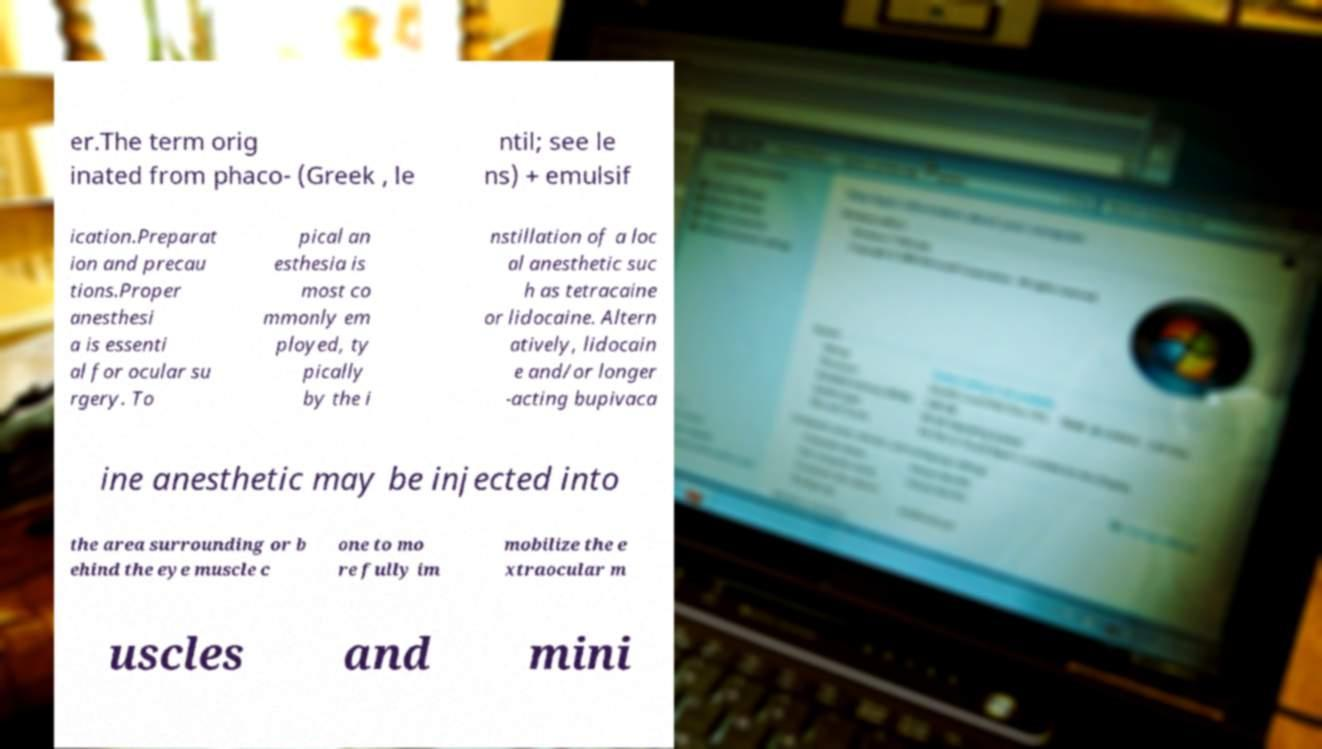What messages or text are displayed in this image? I need them in a readable, typed format. er.The term orig inated from phaco- (Greek , le ntil; see le ns) + emulsif ication.Preparat ion and precau tions.Proper anesthesi a is essenti al for ocular su rgery. To pical an esthesia is most co mmonly em ployed, ty pically by the i nstillation of a loc al anesthetic suc h as tetracaine or lidocaine. Altern atively, lidocain e and/or longer -acting bupivaca ine anesthetic may be injected into the area surrounding or b ehind the eye muscle c one to mo re fully im mobilize the e xtraocular m uscles and mini 